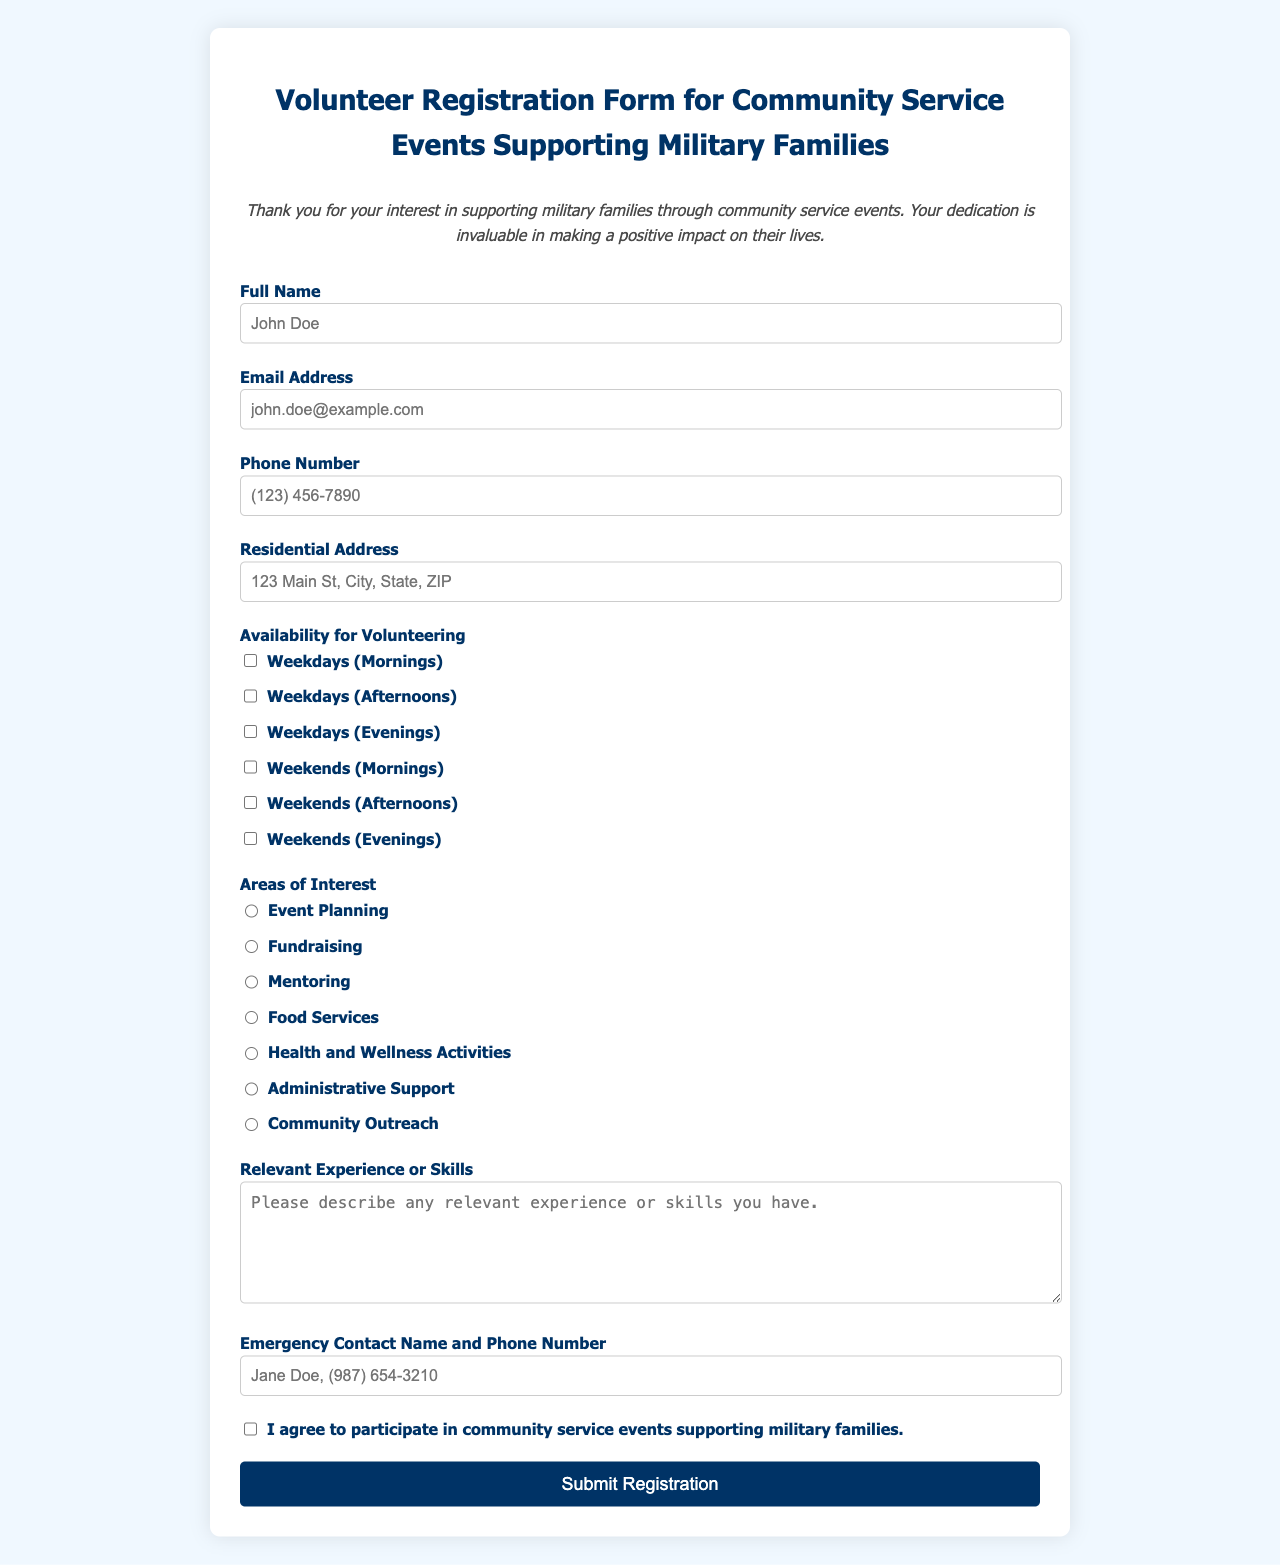What is the title of the form? The title of the form appears at the top of the document and indicates its purpose, which is to register volunteers for community service events.
Answer: Volunteer Registration Form for Community Service Events Supporting Military Families What element of the form requires an email address? The input field labeled "Email Address" requires the user to provide their email information.
Answer: Email Address How many availability options are provided for volunteering? The form includes multiple checkbox options for volunteering, allowing the respondent to select their availability.
Answer: Six Which area of interest is related to planning events? The specific area of interest indicated for organizing and managing events is outlined in the form.
Answer: Event Planning What is the required format for the emergency contact information? The placeholder text in the emergency contact field suggests the expected format for the contact name and phone number.
Answer: Jane Doe, (987) 654-3210 What must a participant agree to before submitting the form? There is a specific checkbox that must be selected to indicate the participant's willingness to engage in activities supporting military families.
Answer: I agree to participate in community service events supporting military families What type of experience or skills section is included in the form? There is an area designated for describing relevant experience or skills that could benefit the volunteering position.
Answer: Relevant Experience or Skills How is the form structured visually? The form is organized with labels, input fields, checkboxes, and sections divided for clarity, following a grid layout.
Answer: Grid layout 